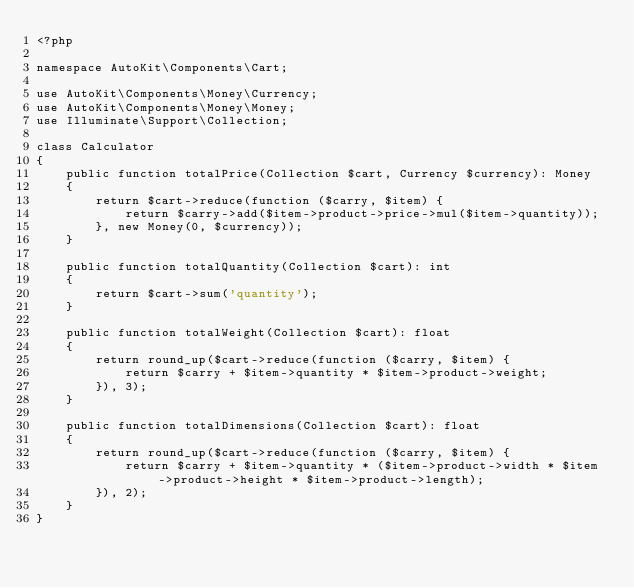<code> <loc_0><loc_0><loc_500><loc_500><_PHP_><?php

namespace AutoKit\Components\Cart;

use AutoKit\Components\Money\Currency;
use AutoKit\Components\Money\Money;
use Illuminate\Support\Collection;

class Calculator
{
    public function totalPrice(Collection $cart, Currency $currency): Money
    {
        return $cart->reduce(function ($carry, $item) {
            return $carry->add($item->product->price->mul($item->quantity));
        }, new Money(0, $currency));
    }

    public function totalQuantity(Collection $cart): int
    {
        return $cart->sum('quantity');
    }

    public function totalWeight(Collection $cart): float
    {
        return round_up($cart->reduce(function ($carry, $item) {
            return $carry + $item->quantity * $item->product->weight;
        }), 3);
    }

    public function totalDimensions(Collection $cart): float
    {
        return round_up($cart->reduce(function ($carry, $item) {
            return $carry + $item->quantity * ($item->product->width * $item->product->height * $item->product->length);
        }), 2);
    }
}</code> 